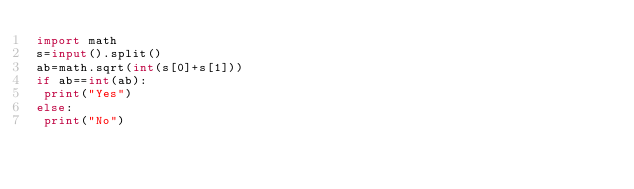<code> <loc_0><loc_0><loc_500><loc_500><_Python_>import math
s=input().split()
ab=math.sqrt(int(s[0]+s[1]))
if ab==int(ab):
 print("Yes")
else:
 print("No")</code> 